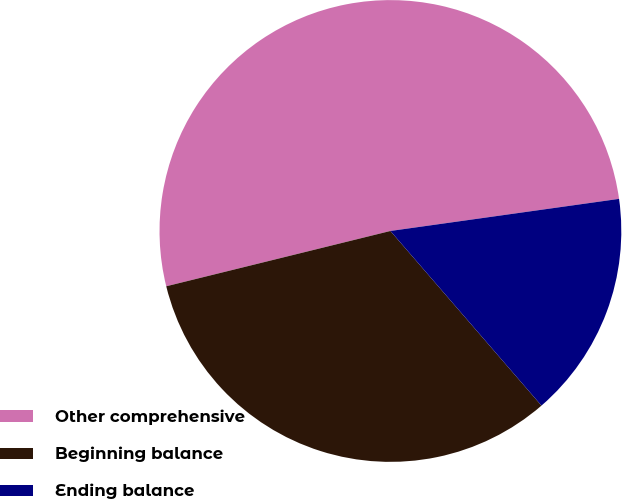<chart> <loc_0><loc_0><loc_500><loc_500><pie_chart><fcel>Other comprehensive<fcel>Beginning balance<fcel>Ending balance<nl><fcel>51.63%<fcel>32.5%<fcel>15.87%<nl></chart> 